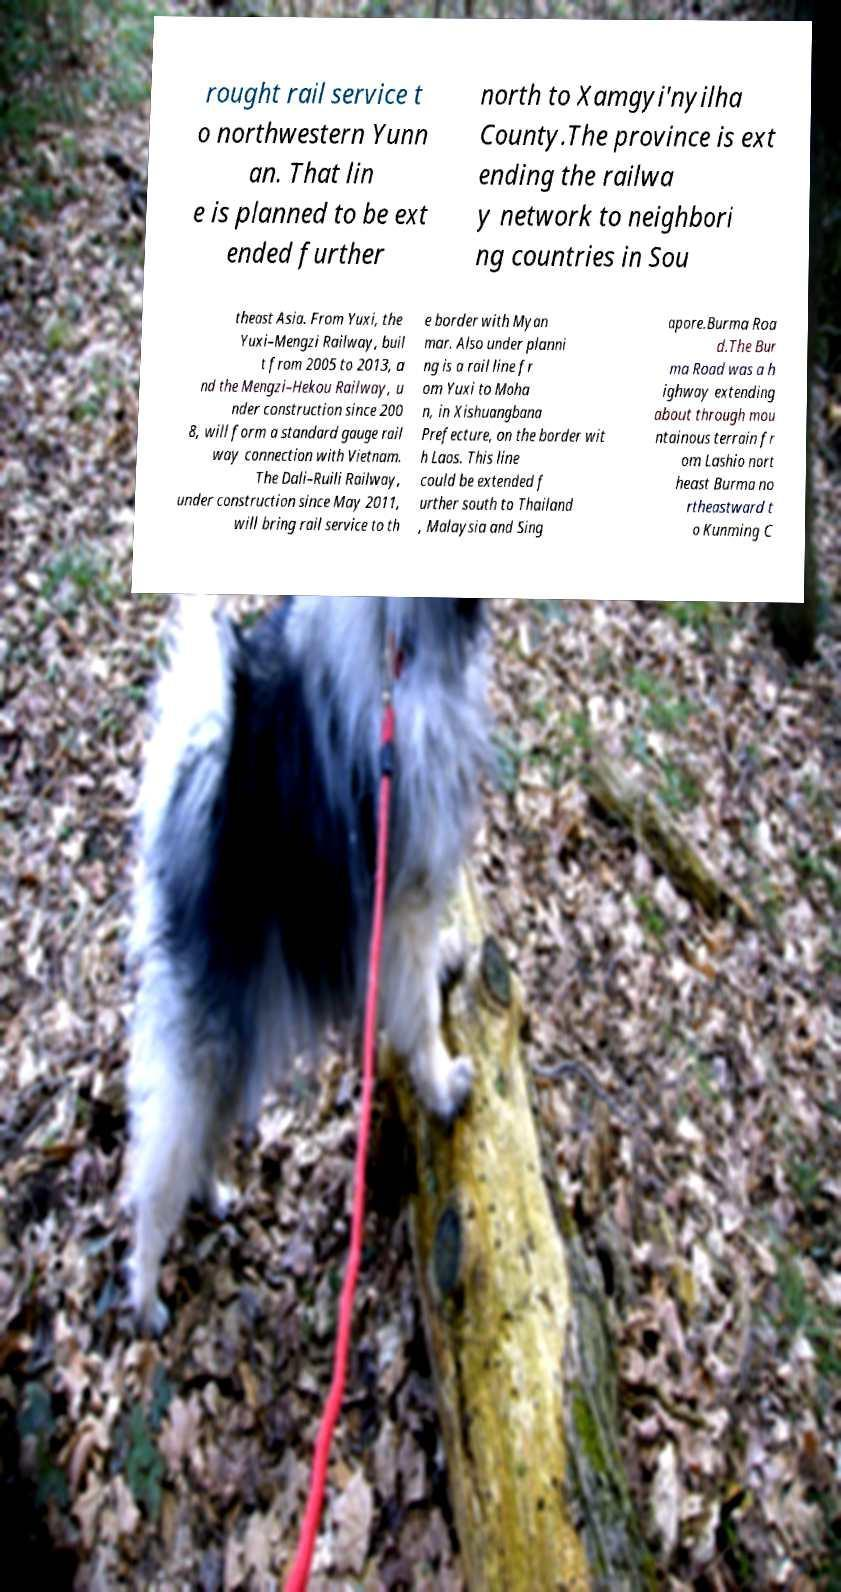Could you extract and type out the text from this image? rought rail service t o northwestern Yunn an. That lin e is planned to be ext ended further north to Xamgyi'nyilha County.The province is ext ending the railwa y network to neighbori ng countries in Sou theast Asia. From Yuxi, the Yuxi–Mengzi Railway, buil t from 2005 to 2013, a nd the Mengzi–Hekou Railway, u nder construction since 200 8, will form a standard gauge rail way connection with Vietnam. The Dali–Ruili Railway, under construction since May 2011, will bring rail service to th e border with Myan mar. Also under planni ng is a rail line fr om Yuxi to Moha n, in Xishuangbana Prefecture, on the border wit h Laos. This line could be extended f urther south to Thailand , Malaysia and Sing apore.Burma Roa d.The Bur ma Road was a h ighway extending about through mou ntainous terrain fr om Lashio nort heast Burma no rtheastward t o Kunming C 